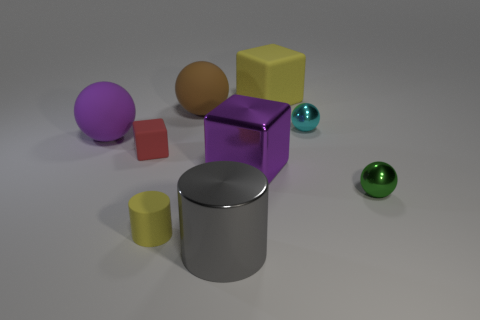What material is the big cube that is the same color as the tiny cylinder?
Offer a terse response. Rubber. Is the gray cylinder the same size as the cyan metal thing?
Your answer should be very brief. No. What number of things are either balls on the left side of the green shiny ball or small things that are behind the green metal object?
Offer a terse response. 4. Is the number of balls that are left of the brown ball greater than the number of tiny brown cylinders?
Give a very brief answer. Yes. How many other objects are the same shape as the small yellow matte thing?
Offer a very short reply. 1. What material is the tiny thing that is both right of the small yellow matte object and behind the purple block?
Give a very brief answer. Metal. What number of objects are either green shiny things or yellow rubber blocks?
Offer a very short reply. 2. Are there more tiny cyan rubber cubes than big metallic cylinders?
Provide a succinct answer. No. There is a metal sphere that is left of the tiny metal sphere in front of the purple matte thing; how big is it?
Offer a terse response. Small. The other rubber thing that is the same shape as the red object is what color?
Provide a short and direct response. Yellow. 